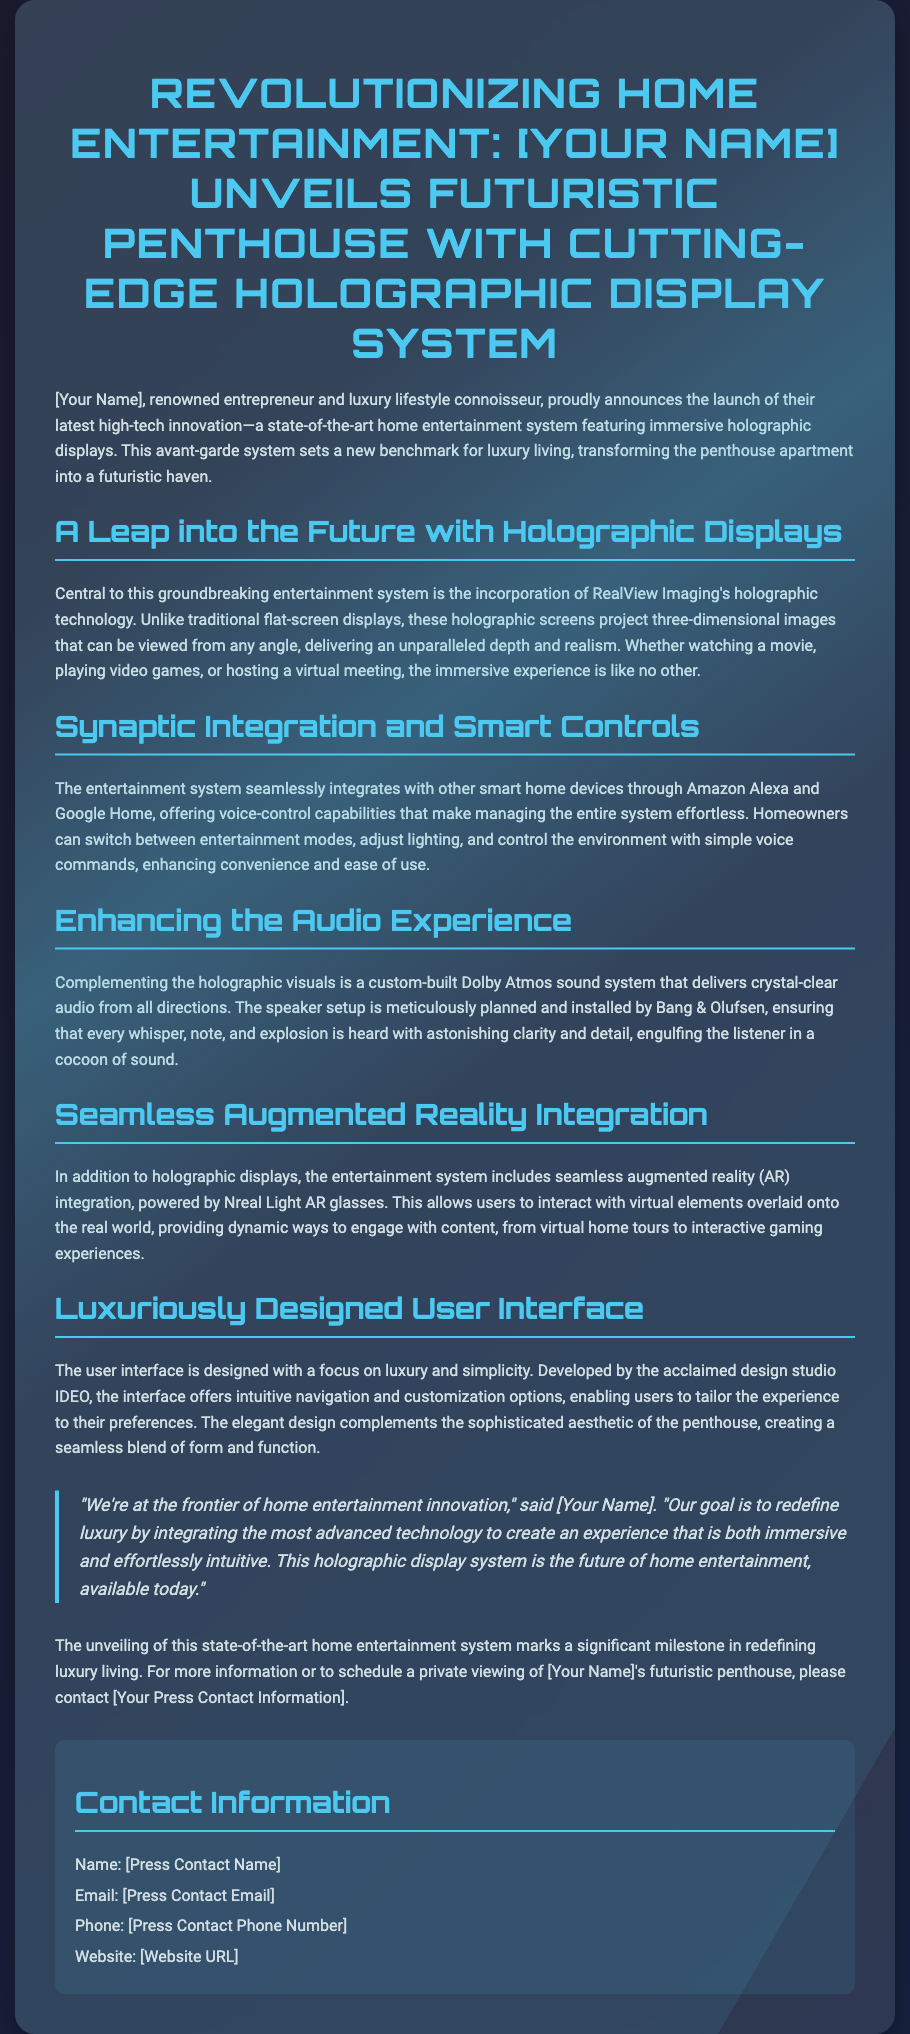what is the name of the entrepreneur launching the system? The document mentions "[Your Name]" as the entrepreneur, which is a placeholder for the actual name.
Answer: [Your Name] what technology powers the holographic displays? The document states that the holographic displays are powered by RealView Imaging's holographic technology.
Answer: RealView Imaging what audio system is mentioned in the press release? The press release details a custom-built Dolby Atmos sound system that complements the holographic visuals.
Answer: Dolby Atmos which design studio developed the user interface? According to the document, the user interface was developed by IDEO, an acclaimed design studio.
Answer: IDEO how does the entertainment system integrate with smart home devices? The entertainment system integrates with smart home devices through Amazon Alexa and Google Home, offering voice-control capabilities.
Answer: Amazon Alexa and Google Home what additional technology enhances user interaction with the entertainment system? The press release mentions seamless augmented reality (AR) integration powered by Nreal Light AR glasses.
Answer: Nreal Light AR glasses who installed the speaker setup for the audio system? The document specifies that the speaker setup was installed by Bang & Olufsen.
Answer: Bang & Olufsen what is the primary goal of the entertainment system according to the entrepreneur? The primary goal stated in the quote is to redefine luxury by integrating advanced technology for an immersive experience.
Answer: Redefine luxury what is the call to action at the end of the press release? The document encourages readers to contact for information or schedule a private viewing of the penthouse.
Answer: Schedule a private viewing 